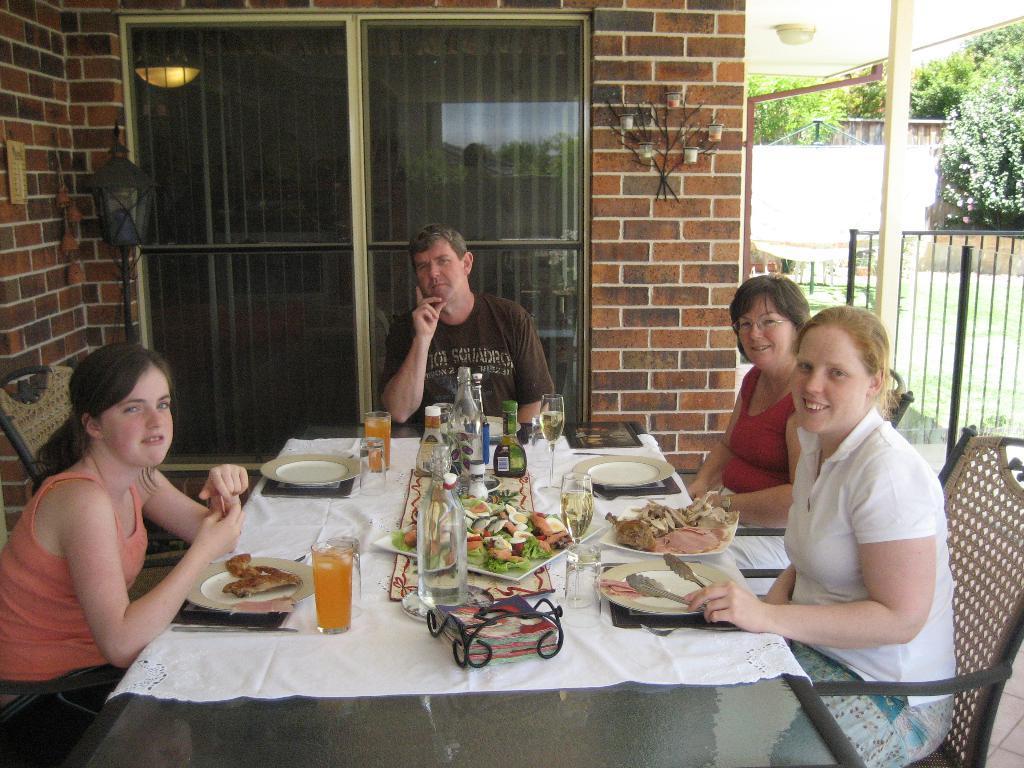Describe this image in one or two sentences. In this picture there are three women and a man sitting on a chair. There is a glass, table, food in the plate. There is a tong and other objects on the table. There is a light. There are some trees at the background. 